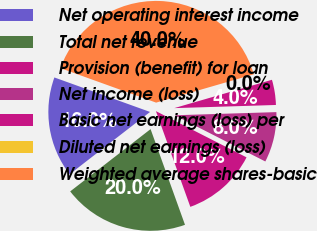<chart> <loc_0><loc_0><loc_500><loc_500><pie_chart><fcel>Net operating interest income<fcel>Total net revenue<fcel>Provision (benefit) for loan<fcel>Net income (loss)<fcel>Basic net earnings (loss) per<fcel>Diluted net earnings (loss)<fcel>Weighted average shares-basic<nl><fcel>16.0%<fcel>20.0%<fcel>12.0%<fcel>8.0%<fcel>4.0%<fcel>0.0%<fcel>40.0%<nl></chart> 